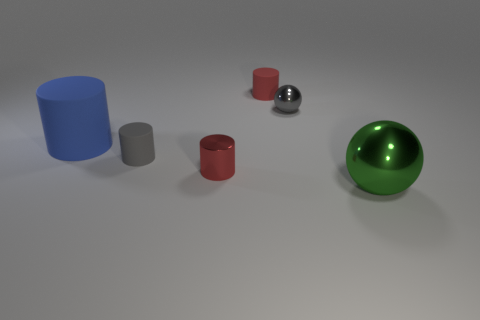Add 1 tiny gray cylinders. How many objects exist? 7 Subtract all cylinders. How many objects are left? 2 Add 2 big brown metallic spheres. How many big brown metallic spheres exist? 2 Subtract 1 blue cylinders. How many objects are left? 5 Subtract all rubber things. Subtract all small red objects. How many objects are left? 1 Add 3 metallic balls. How many metallic balls are left? 5 